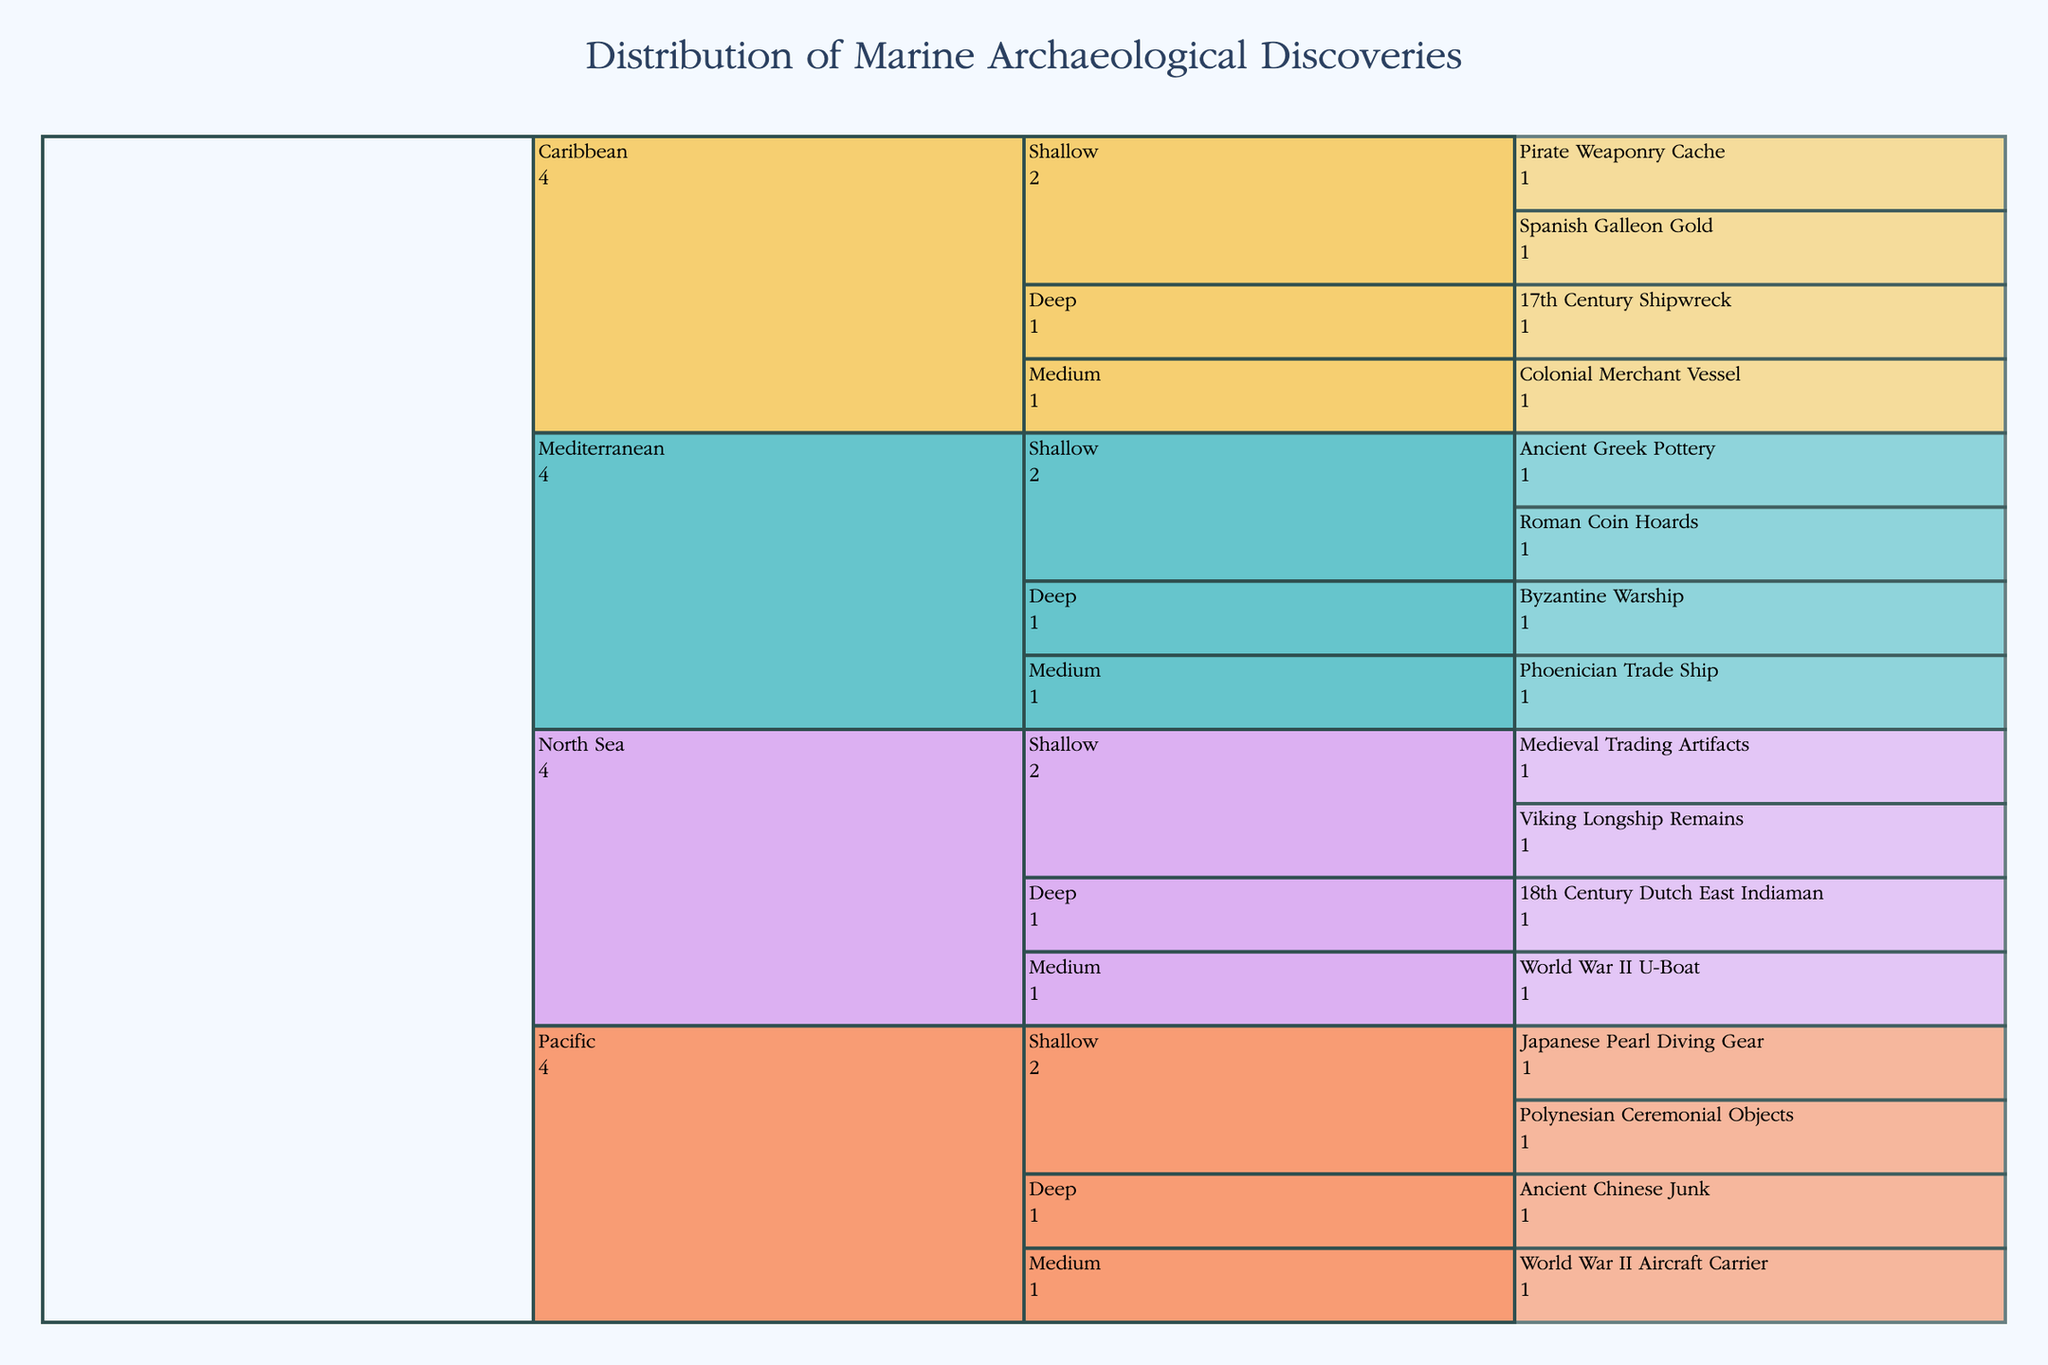What's the title of the figure? The title is usually prominently displayed at the top of the chart. In this case, the title reads "Distribution of Marine Archaeological Discoveries". This helps set the context for the data being visualized.
Answer: Distribution of Marine Archaeological Discoveries Which region has the most deep-water discoveries? To answer this, you need to observe the segments labeled "Deep" under each region. Compare the number of discoveries shown in the Deep segment across the Mediterranean, Caribbean, North Sea, and Pacific sections. The Mediterranean has one discovery (Byzantine Warship), Caribbean has one (17th Century Shipwreck), North Sea has one (18th Century Dutch East Indiaman), and the Pacific has one (Ancient Chinese Junk). They all have the same number.
Answer: All regions have 1 How many discoveries are listed under "Medium" depth in the North Sea? Look at the section labeled "Medium" under the North Sea. The chart shows one discovery there.
Answer: 1 Which region has discoveries from the most time periods based on the names? The time periods of discoveries can be inferred from the names. For example, the Mediterranean has discoveries from Ancient Greek, Roman, Phoenician, and Byzantine times. Compare this with other regions to see that the Mediterranean has the most varied time periods.
Answer: Mediterranean How many discoveries are there in total for all shallow depths combined? Identify all shallow depth sections across all regions and count the number of discoveries listed: Mediterranean (2), Caribbean (2), North Sea (2), Pacific (2). Summing these up gives 2 + 2 + 2 + 2 = 8.
Answer: 8 Which region features World War II artifacts, and at what depths are they found? Look for labels mentioning World War II within the regions. You'll see that the North Sea has a "World War II U-Boat" under Medium depth, and the Pacific has a "World War II Aircraft Carrier" under Medium depth.
Answer: North Sea and Pacific, Medium What is the deepest listed discovery related to the Vikings? Find "Viking" related artifacts and note their depth. The Viking Longship Remains are found at the shallow depth in the North Sea, and there are no deeper listings for Viking artifacts across any other region.
Answer: Shallow Which regions share a discovery related to trade or merchant ships? Look for terms like "Trade Ship" or "Merchant Vessel". The Mediterranean has a Phoenician Trade Ship (Medium depth), and the Caribbean has a Colonial Merchant Vessel (Medium depth).
Answer: Mediterranean and Caribbean Are there more discoveries at shallow depths or medium depths in the Pacific? Count the number of listed discoveries under the Pacific region for shallow (2: Polynesian Ceremonial Objects, Japanese Pearl Diving Gear) and medium depths (1: World War II Aircraft Carrier). Comparison shows there are more at shallow depths.
Answer: Shallow Which depth and region combination features the oldest listed discovery? Look for descriptions indicating age. "Ancient Greek Pottery" in the Mediterranean at shallow depth mentions "Ancient", implying it is among the oldest.
Answer: Shallow, Mediterranean 